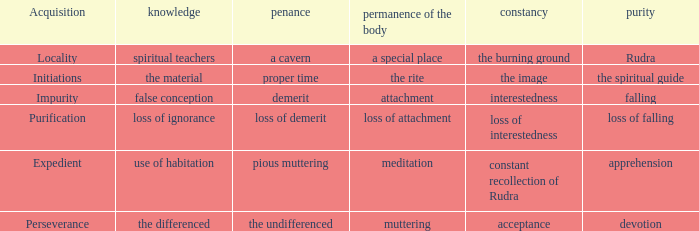What is the total number of constancy where purity is falling 1.0. Write the full table. {'header': ['Acquisition', 'knowledge', 'penance', 'permanence of the body', 'constancy', 'purity'], 'rows': [['Locality', 'spiritual teachers', 'a cavern', 'a special place', 'the burning ground', 'Rudra'], ['Initiations', 'the material', 'proper time', 'the rite', 'the image', 'the spiritual guide'], ['Impurity', 'false conception', 'demerit', 'attachment', 'interestedness', 'falling'], ['Purification', 'loss of ignorance', 'loss of demerit', 'loss of attachment', 'loss of interestedness', 'loss of falling'], ['Expedient', 'use of habitation', 'pious muttering', 'meditation', 'constant recollection of Rudra', 'apprehension'], ['Perseverance', 'the differenced', 'the undifferenced', 'muttering', 'acceptance', 'devotion']]} 